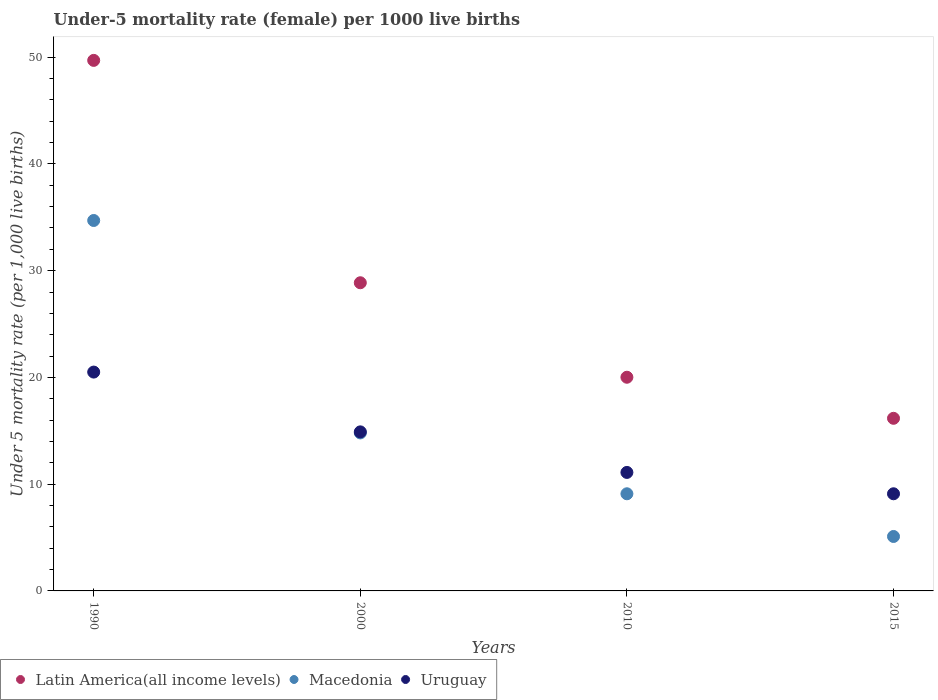How many different coloured dotlines are there?
Provide a succinct answer. 3. Is the number of dotlines equal to the number of legend labels?
Your response must be concise. Yes. Across all years, what is the maximum under-five mortality rate in Uruguay?
Offer a terse response. 20.5. In which year was the under-five mortality rate in Latin America(all income levels) minimum?
Give a very brief answer. 2015. What is the total under-five mortality rate in Latin America(all income levels) in the graph?
Keep it short and to the point. 114.75. What is the difference between the under-five mortality rate in Macedonia in 2000 and that in 2010?
Keep it short and to the point. 5.7. What is the difference between the under-five mortality rate in Macedonia in 2000 and the under-five mortality rate in Uruguay in 2010?
Offer a terse response. 3.7. What is the average under-five mortality rate in Macedonia per year?
Your answer should be very brief. 15.93. In the year 1990, what is the difference between the under-five mortality rate in Uruguay and under-five mortality rate in Macedonia?
Offer a terse response. -14.2. In how many years, is the under-five mortality rate in Uruguay greater than 40?
Give a very brief answer. 0. What is the ratio of the under-five mortality rate in Uruguay in 1990 to that in 2015?
Give a very brief answer. 2.25. Is the difference between the under-five mortality rate in Uruguay in 1990 and 2015 greater than the difference between the under-five mortality rate in Macedonia in 1990 and 2015?
Your answer should be compact. No. What is the difference between the highest and the second highest under-five mortality rate in Latin America(all income levels)?
Offer a terse response. 20.83. What is the difference between the highest and the lowest under-five mortality rate in Macedonia?
Your answer should be very brief. 29.6. Is the sum of the under-five mortality rate in Uruguay in 2000 and 2010 greater than the maximum under-five mortality rate in Latin America(all income levels) across all years?
Offer a terse response. No. Is the under-five mortality rate in Uruguay strictly greater than the under-five mortality rate in Latin America(all income levels) over the years?
Offer a terse response. No. Is the under-five mortality rate in Uruguay strictly less than the under-five mortality rate in Macedonia over the years?
Make the answer very short. No. How many years are there in the graph?
Make the answer very short. 4. What is the difference between two consecutive major ticks on the Y-axis?
Your answer should be compact. 10. Does the graph contain any zero values?
Your response must be concise. No. Where does the legend appear in the graph?
Provide a succinct answer. Bottom left. How many legend labels are there?
Keep it short and to the point. 3. How are the legend labels stacked?
Give a very brief answer. Horizontal. What is the title of the graph?
Keep it short and to the point. Under-5 mortality rate (female) per 1000 live births. What is the label or title of the Y-axis?
Keep it short and to the point. Under 5 mortality rate (per 1,0 live births). What is the Under 5 mortality rate (per 1,000 live births) in Latin America(all income levels) in 1990?
Make the answer very short. 49.7. What is the Under 5 mortality rate (per 1,000 live births) in Macedonia in 1990?
Provide a succinct answer. 34.7. What is the Under 5 mortality rate (per 1,000 live births) of Latin America(all income levels) in 2000?
Your response must be concise. 28.87. What is the Under 5 mortality rate (per 1,000 live births) of Uruguay in 2000?
Offer a very short reply. 14.9. What is the Under 5 mortality rate (per 1,000 live births) in Latin America(all income levels) in 2010?
Provide a short and direct response. 20.02. What is the Under 5 mortality rate (per 1,000 live births) in Uruguay in 2010?
Offer a terse response. 11.1. What is the Under 5 mortality rate (per 1,000 live births) of Latin America(all income levels) in 2015?
Offer a very short reply. 16.17. What is the Under 5 mortality rate (per 1,000 live births) of Macedonia in 2015?
Ensure brevity in your answer.  5.1. What is the Under 5 mortality rate (per 1,000 live births) of Uruguay in 2015?
Keep it short and to the point. 9.1. Across all years, what is the maximum Under 5 mortality rate (per 1,000 live births) of Latin America(all income levels)?
Your response must be concise. 49.7. Across all years, what is the maximum Under 5 mortality rate (per 1,000 live births) in Macedonia?
Provide a short and direct response. 34.7. Across all years, what is the minimum Under 5 mortality rate (per 1,000 live births) of Latin America(all income levels)?
Your answer should be very brief. 16.17. What is the total Under 5 mortality rate (per 1,000 live births) in Latin America(all income levels) in the graph?
Your answer should be very brief. 114.75. What is the total Under 5 mortality rate (per 1,000 live births) of Macedonia in the graph?
Keep it short and to the point. 63.7. What is the total Under 5 mortality rate (per 1,000 live births) in Uruguay in the graph?
Keep it short and to the point. 55.6. What is the difference between the Under 5 mortality rate (per 1,000 live births) in Latin America(all income levels) in 1990 and that in 2000?
Offer a terse response. 20.83. What is the difference between the Under 5 mortality rate (per 1,000 live births) in Latin America(all income levels) in 1990 and that in 2010?
Ensure brevity in your answer.  29.68. What is the difference between the Under 5 mortality rate (per 1,000 live births) in Macedonia in 1990 and that in 2010?
Your answer should be very brief. 25.6. What is the difference between the Under 5 mortality rate (per 1,000 live births) of Uruguay in 1990 and that in 2010?
Provide a succinct answer. 9.4. What is the difference between the Under 5 mortality rate (per 1,000 live births) in Latin America(all income levels) in 1990 and that in 2015?
Provide a short and direct response. 33.53. What is the difference between the Under 5 mortality rate (per 1,000 live births) in Macedonia in 1990 and that in 2015?
Provide a succinct answer. 29.6. What is the difference between the Under 5 mortality rate (per 1,000 live births) in Latin America(all income levels) in 2000 and that in 2010?
Provide a succinct answer. 8.85. What is the difference between the Under 5 mortality rate (per 1,000 live births) of Latin America(all income levels) in 2000 and that in 2015?
Your answer should be very brief. 12.7. What is the difference between the Under 5 mortality rate (per 1,000 live births) in Macedonia in 2000 and that in 2015?
Offer a very short reply. 9.7. What is the difference between the Under 5 mortality rate (per 1,000 live births) in Latin America(all income levels) in 2010 and that in 2015?
Your answer should be compact. 3.85. What is the difference between the Under 5 mortality rate (per 1,000 live births) of Latin America(all income levels) in 1990 and the Under 5 mortality rate (per 1,000 live births) of Macedonia in 2000?
Your response must be concise. 34.9. What is the difference between the Under 5 mortality rate (per 1,000 live births) of Latin America(all income levels) in 1990 and the Under 5 mortality rate (per 1,000 live births) of Uruguay in 2000?
Provide a succinct answer. 34.8. What is the difference between the Under 5 mortality rate (per 1,000 live births) in Macedonia in 1990 and the Under 5 mortality rate (per 1,000 live births) in Uruguay in 2000?
Your answer should be very brief. 19.8. What is the difference between the Under 5 mortality rate (per 1,000 live births) of Latin America(all income levels) in 1990 and the Under 5 mortality rate (per 1,000 live births) of Macedonia in 2010?
Your answer should be compact. 40.6. What is the difference between the Under 5 mortality rate (per 1,000 live births) of Latin America(all income levels) in 1990 and the Under 5 mortality rate (per 1,000 live births) of Uruguay in 2010?
Your answer should be very brief. 38.6. What is the difference between the Under 5 mortality rate (per 1,000 live births) of Macedonia in 1990 and the Under 5 mortality rate (per 1,000 live births) of Uruguay in 2010?
Your answer should be very brief. 23.6. What is the difference between the Under 5 mortality rate (per 1,000 live births) in Latin America(all income levels) in 1990 and the Under 5 mortality rate (per 1,000 live births) in Macedonia in 2015?
Give a very brief answer. 44.6. What is the difference between the Under 5 mortality rate (per 1,000 live births) in Latin America(all income levels) in 1990 and the Under 5 mortality rate (per 1,000 live births) in Uruguay in 2015?
Your answer should be compact. 40.6. What is the difference between the Under 5 mortality rate (per 1,000 live births) of Macedonia in 1990 and the Under 5 mortality rate (per 1,000 live births) of Uruguay in 2015?
Your answer should be compact. 25.6. What is the difference between the Under 5 mortality rate (per 1,000 live births) of Latin America(all income levels) in 2000 and the Under 5 mortality rate (per 1,000 live births) of Macedonia in 2010?
Ensure brevity in your answer.  19.77. What is the difference between the Under 5 mortality rate (per 1,000 live births) of Latin America(all income levels) in 2000 and the Under 5 mortality rate (per 1,000 live births) of Uruguay in 2010?
Ensure brevity in your answer.  17.77. What is the difference between the Under 5 mortality rate (per 1,000 live births) of Macedonia in 2000 and the Under 5 mortality rate (per 1,000 live births) of Uruguay in 2010?
Give a very brief answer. 3.7. What is the difference between the Under 5 mortality rate (per 1,000 live births) in Latin America(all income levels) in 2000 and the Under 5 mortality rate (per 1,000 live births) in Macedonia in 2015?
Offer a very short reply. 23.77. What is the difference between the Under 5 mortality rate (per 1,000 live births) of Latin America(all income levels) in 2000 and the Under 5 mortality rate (per 1,000 live births) of Uruguay in 2015?
Keep it short and to the point. 19.77. What is the difference between the Under 5 mortality rate (per 1,000 live births) of Macedonia in 2000 and the Under 5 mortality rate (per 1,000 live births) of Uruguay in 2015?
Your response must be concise. 5.7. What is the difference between the Under 5 mortality rate (per 1,000 live births) in Latin America(all income levels) in 2010 and the Under 5 mortality rate (per 1,000 live births) in Macedonia in 2015?
Your answer should be very brief. 14.92. What is the difference between the Under 5 mortality rate (per 1,000 live births) of Latin America(all income levels) in 2010 and the Under 5 mortality rate (per 1,000 live births) of Uruguay in 2015?
Your answer should be very brief. 10.92. What is the average Under 5 mortality rate (per 1,000 live births) of Latin America(all income levels) per year?
Offer a terse response. 28.69. What is the average Under 5 mortality rate (per 1,000 live births) in Macedonia per year?
Provide a succinct answer. 15.93. In the year 1990, what is the difference between the Under 5 mortality rate (per 1,000 live births) in Latin America(all income levels) and Under 5 mortality rate (per 1,000 live births) in Macedonia?
Provide a short and direct response. 15. In the year 1990, what is the difference between the Under 5 mortality rate (per 1,000 live births) in Latin America(all income levels) and Under 5 mortality rate (per 1,000 live births) in Uruguay?
Offer a very short reply. 29.2. In the year 1990, what is the difference between the Under 5 mortality rate (per 1,000 live births) in Macedonia and Under 5 mortality rate (per 1,000 live births) in Uruguay?
Give a very brief answer. 14.2. In the year 2000, what is the difference between the Under 5 mortality rate (per 1,000 live births) of Latin America(all income levels) and Under 5 mortality rate (per 1,000 live births) of Macedonia?
Provide a short and direct response. 14.07. In the year 2000, what is the difference between the Under 5 mortality rate (per 1,000 live births) in Latin America(all income levels) and Under 5 mortality rate (per 1,000 live births) in Uruguay?
Your response must be concise. 13.97. In the year 2010, what is the difference between the Under 5 mortality rate (per 1,000 live births) of Latin America(all income levels) and Under 5 mortality rate (per 1,000 live births) of Macedonia?
Give a very brief answer. 10.92. In the year 2010, what is the difference between the Under 5 mortality rate (per 1,000 live births) of Latin America(all income levels) and Under 5 mortality rate (per 1,000 live births) of Uruguay?
Provide a succinct answer. 8.92. In the year 2015, what is the difference between the Under 5 mortality rate (per 1,000 live births) in Latin America(all income levels) and Under 5 mortality rate (per 1,000 live births) in Macedonia?
Your answer should be compact. 11.07. In the year 2015, what is the difference between the Under 5 mortality rate (per 1,000 live births) of Latin America(all income levels) and Under 5 mortality rate (per 1,000 live births) of Uruguay?
Provide a short and direct response. 7.07. In the year 2015, what is the difference between the Under 5 mortality rate (per 1,000 live births) in Macedonia and Under 5 mortality rate (per 1,000 live births) in Uruguay?
Your answer should be compact. -4. What is the ratio of the Under 5 mortality rate (per 1,000 live births) of Latin America(all income levels) in 1990 to that in 2000?
Make the answer very short. 1.72. What is the ratio of the Under 5 mortality rate (per 1,000 live births) of Macedonia in 1990 to that in 2000?
Provide a succinct answer. 2.34. What is the ratio of the Under 5 mortality rate (per 1,000 live births) of Uruguay in 1990 to that in 2000?
Provide a succinct answer. 1.38. What is the ratio of the Under 5 mortality rate (per 1,000 live births) of Latin America(all income levels) in 1990 to that in 2010?
Make the answer very short. 2.48. What is the ratio of the Under 5 mortality rate (per 1,000 live births) of Macedonia in 1990 to that in 2010?
Your response must be concise. 3.81. What is the ratio of the Under 5 mortality rate (per 1,000 live births) in Uruguay in 1990 to that in 2010?
Keep it short and to the point. 1.85. What is the ratio of the Under 5 mortality rate (per 1,000 live births) in Latin America(all income levels) in 1990 to that in 2015?
Keep it short and to the point. 3.07. What is the ratio of the Under 5 mortality rate (per 1,000 live births) in Macedonia in 1990 to that in 2015?
Offer a terse response. 6.8. What is the ratio of the Under 5 mortality rate (per 1,000 live births) of Uruguay in 1990 to that in 2015?
Give a very brief answer. 2.25. What is the ratio of the Under 5 mortality rate (per 1,000 live births) of Latin America(all income levels) in 2000 to that in 2010?
Your response must be concise. 1.44. What is the ratio of the Under 5 mortality rate (per 1,000 live births) of Macedonia in 2000 to that in 2010?
Your answer should be compact. 1.63. What is the ratio of the Under 5 mortality rate (per 1,000 live births) in Uruguay in 2000 to that in 2010?
Make the answer very short. 1.34. What is the ratio of the Under 5 mortality rate (per 1,000 live births) in Latin America(all income levels) in 2000 to that in 2015?
Provide a succinct answer. 1.79. What is the ratio of the Under 5 mortality rate (per 1,000 live births) in Macedonia in 2000 to that in 2015?
Make the answer very short. 2.9. What is the ratio of the Under 5 mortality rate (per 1,000 live births) in Uruguay in 2000 to that in 2015?
Offer a very short reply. 1.64. What is the ratio of the Under 5 mortality rate (per 1,000 live births) of Latin America(all income levels) in 2010 to that in 2015?
Offer a terse response. 1.24. What is the ratio of the Under 5 mortality rate (per 1,000 live births) of Macedonia in 2010 to that in 2015?
Make the answer very short. 1.78. What is the ratio of the Under 5 mortality rate (per 1,000 live births) in Uruguay in 2010 to that in 2015?
Offer a very short reply. 1.22. What is the difference between the highest and the second highest Under 5 mortality rate (per 1,000 live births) in Latin America(all income levels)?
Provide a succinct answer. 20.83. What is the difference between the highest and the lowest Under 5 mortality rate (per 1,000 live births) in Latin America(all income levels)?
Offer a terse response. 33.53. What is the difference between the highest and the lowest Under 5 mortality rate (per 1,000 live births) in Macedonia?
Offer a terse response. 29.6. 